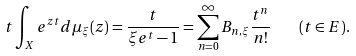<formula> <loc_0><loc_0><loc_500><loc_500>t \int _ { X } e ^ { z t } d \mu _ { \xi } ( z ) = \frac { t } { \xi e ^ { t } - 1 } = \sum _ { n = 0 } ^ { \infty } B _ { n , \xi } \frac { t ^ { n } } { n ! } \quad ( t \in E ) .</formula> 